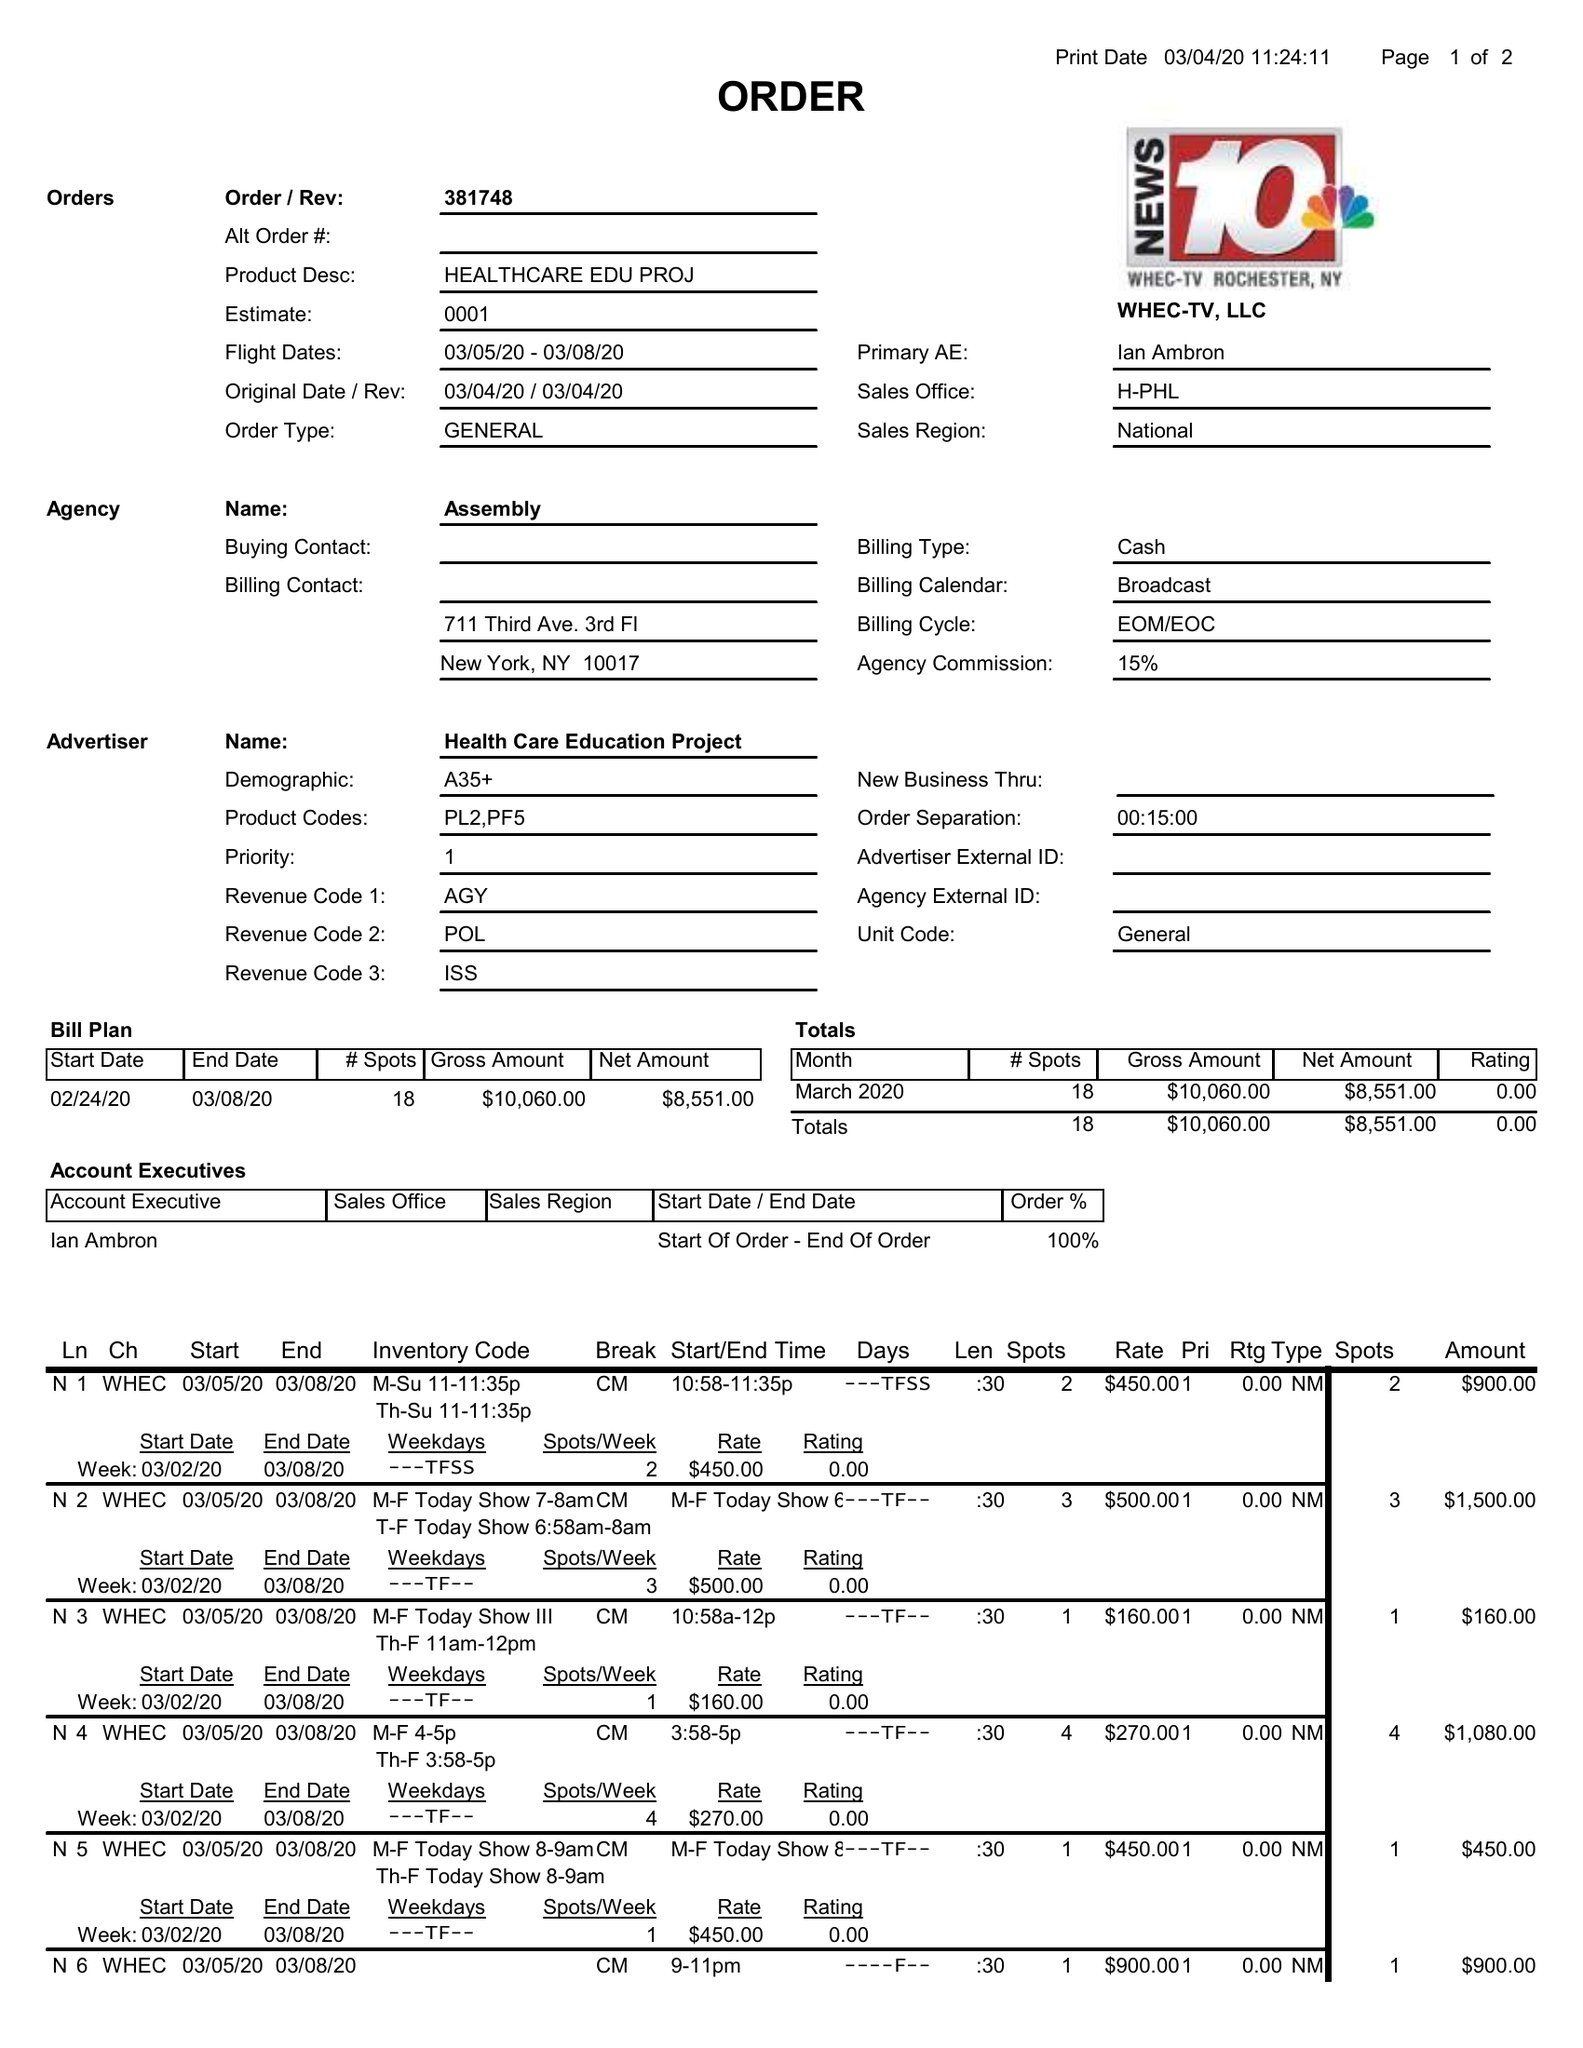What is the value for the gross_amount?
Answer the question using a single word or phrase. 10060.00 